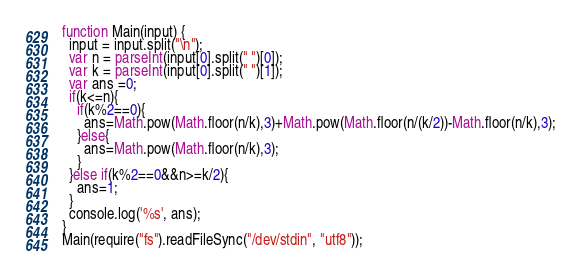<code> <loc_0><loc_0><loc_500><loc_500><_JavaScript_>function Main(input) {
  input = input.split("\n");
  var n = parseInt(input[0].split(" ")[0]);
  var k = parseInt(input[0].split(" ")[1]);
  var ans =0;
  if(k<=n){
    if(k%2==0){
      ans=Math.pow(Math.floor(n/k),3)+Math.pow(Math.floor(n/(k/2))-Math.floor(n/k),3);
    }else{
      ans=Math.pow(Math.floor(n/k),3);
    }
  }else if(k%2==0&&n>=k/2){
    ans=1;
  }
  console.log('%s', ans);
}
Main(require("fs").readFileSync("/dev/stdin", "utf8"));</code> 